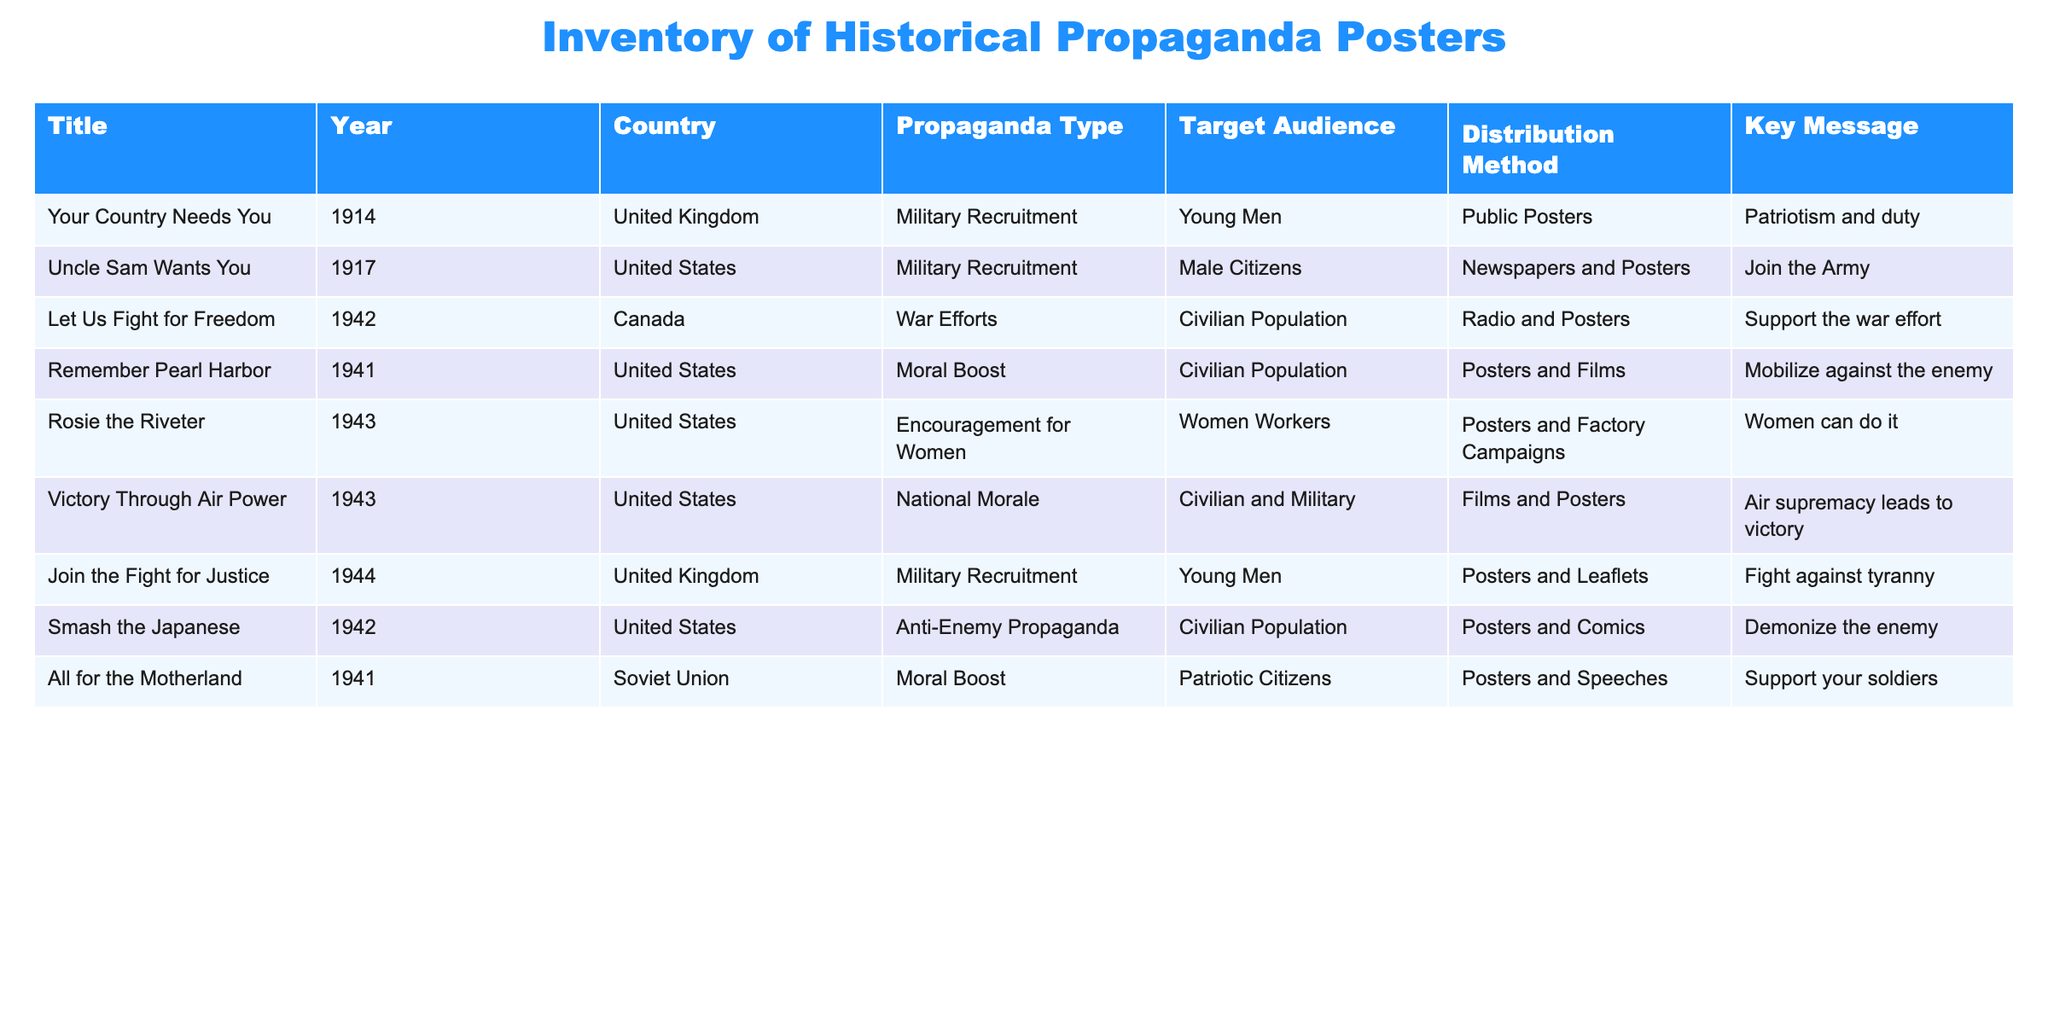What is the title of the propaganda poster aimed at women workers? The table lists the propaganda posters, and under the "Title" column, the entry for "Rosie the Riveter" is associated with the "Target Audience" indicating "Women Workers."
Answer: Rosie the Riveter Which year did Canada produce a propaganda poster supporting war efforts? In the table, there is an entry with the "Country" as Canada and the "Year" as 1942, which corresponds to the title "Let Us Fight for Freedom."
Answer: 1942 How many propaganda posters specifically targeted young men? To find the answer, we can look at the "Target Audience" column for entries labeled "Young Men." These include "Your Country Needs You," "Join the Fight for Justice," making it a total of two posters targeting that demographic.
Answer: 2 Did the United States produce any moral boost propaganda posters in 1941? The table indicates that in 1941, the United States did indeed produce a poster titled "Remember Pearl Harbor," aimed at boosting civilian morale, thus confirming the statement.
Answer: Yes In the given data, which country had the earliest propaganda poster aimed at military recruitment? The "Year" column indicates the earliest military recruitment poster was "Your Country Needs You," produced in 1914 by the United Kingdom, making it the earliest in the given data.
Answer: United Kingdom What percentage of the propaganda posters in the table were disseminated through public posters? There are a total of nine posters in the table. The posters that were distributed via public posters include: "Your Country Needs You," "Join the Fight for Justice," and "Smash the Japanese," totaling three. Thus, the percentage is (3/9)*100 = 33.33%.
Answer: 33.33% Which distribution method was used for the most propaganda posters? By scanning the "Distribution Method" column, we find that Posters appear most frequently in association with military recruitment and moral boost messages, particularly in the entries from the United States. Counting these up gives us the maximum occurrences.
Answer: Posters If we were to compare the key messages of the propaganda posters targeting the civilian population, what is the focus? By reviewing the "Key Message" of entries targeting the "Civilian Population," we can see there are different focuses: "Support the war effort" (Canada), "Mobilize against the enemy" (United States, 1941), and "Air supremacy leads to victory" (United States, 1943), collectively emphasizing unity and commitment during wartime.
Answer: Unity and commitment 